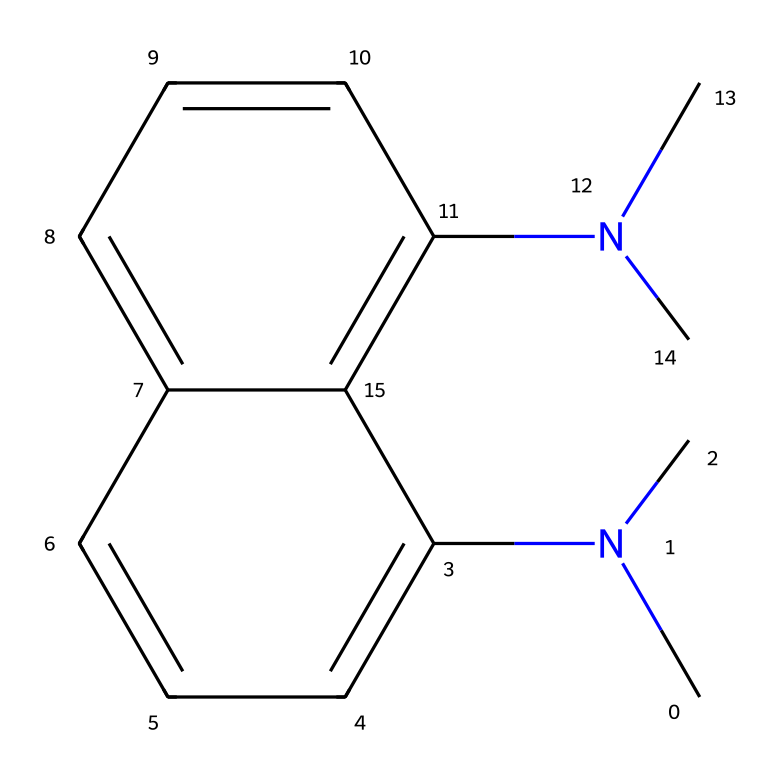What is the primary functional group present in this structure? The structure contains multiple nitrogen atoms bonded to carbon atoms, indicating the presence of amine functional groups. The two dimethylamino groups specifically highlight this characteristic.
Answer: amine How many rings are present in the chemical structure? The structure shows a fused ring system, which includes two distinct aromatic rings that are connected, indicating two rings in total.
Answer: 2 What is the molecular formula of 1,8-bis(dimethylamino)naphthalene? By counting the number of carbon (C), hydrogen (H), and nitrogen (N) atoms in the SMILES, we find C12, H16, and N2, leading to the molecular formula C12H16N2.
Answer: C12H16N2 What type of acidity is 1,8-bis(dimethylamino)naphthalene particularly known for? This compound is well-known for its ability to act as a strong base due to the presence of the dimethylamino groups, which can accept protons readily, thus exhibiting superbase behavior.
Answer: superbase How many nitrogen atoms are present in this molecule? By examining the structure, we can identify that there are two distinct nitrogen atoms included within the dimethylamino groups attached to the naphthalene framework.
Answer: 2 What contributes to the superbase nature of 1,8-bis(dimethylamino)naphthalene? The enhanced electron density provided by the two dimethylamino groups significantly increases its ability to deprotonate weak acids, a hallmark of superbasic behavior, compared to typical bases.
Answer: electron density 